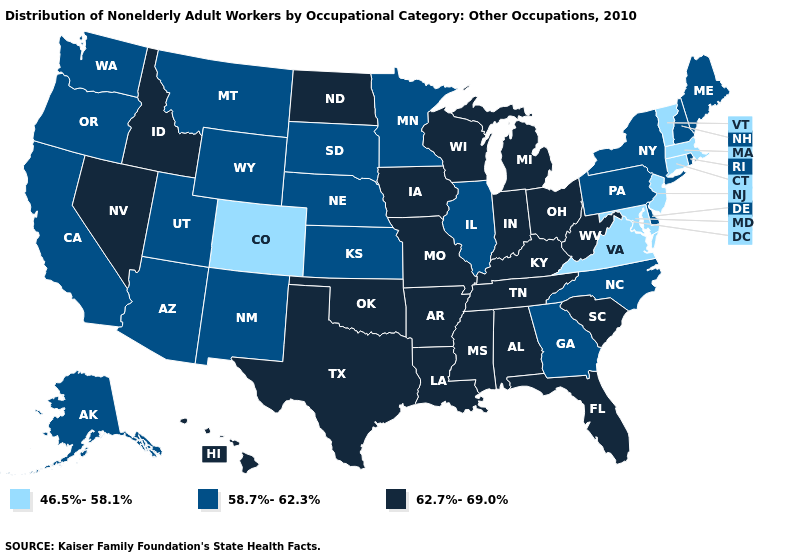What is the value of California?
Short answer required. 58.7%-62.3%. Does Connecticut have the lowest value in the Northeast?
Concise answer only. Yes. What is the highest value in states that border Mississippi?
Short answer required. 62.7%-69.0%. Does Wyoming have the highest value in the USA?
Keep it brief. No. Does Vermont have a higher value than South Carolina?
Give a very brief answer. No. What is the highest value in the Northeast ?
Give a very brief answer. 58.7%-62.3%. Among the states that border Rhode Island , which have the highest value?
Answer briefly. Connecticut, Massachusetts. Name the states that have a value in the range 46.5%-58.1%?
Concise answer only. Colorado, Connecticut, Maryland, Massachusetts, New Jersey, Vermont, Virginia. Which states hav the highest value in the Northeast?
Concise answer only. Maine, New Hampshire, New York, Pennsylvania, Rhode Island. What is the value of Kentucky?
Keep it brief. 62.7%-69.0%. Name the states that have a value in the range 62.7%-69.0%?
Give a very brief answer. Alabama, Arkansas, Florida, Hawaii, Idaho, Indiana, Iowa, Kentucky, Louisiana, Michigan, Mississippi, Missouri, Nevada, North Dakota, Ohio, Oklahoma, South Carolina, Tennessee, Texas, West Virginia, Wisconsin. Among the states that border Arkansas , which have the highest value?
Concise answer only. Louisiana, Mississippi, Missouri, Oklahoma, Tennessee, Texas. What is the lowest value in the MidWest?
Be succinct. 58.7%-62.3%. Which states have the highest value in the USA?
Write a very short answer. Alabama, Arkansas, Florida, Hawaii, Idaho, Indiana, Iowa, Kentucky, Louisiana, Michigan, Mississippi, Missouri, Nevada, North Dakota, Ohio, Oklahoma, South Carolina, Tennessee, Texas, West Virginia, Wisconsin. Which states have the lowest value in the West?
Give a very brief answer. Colorado. 